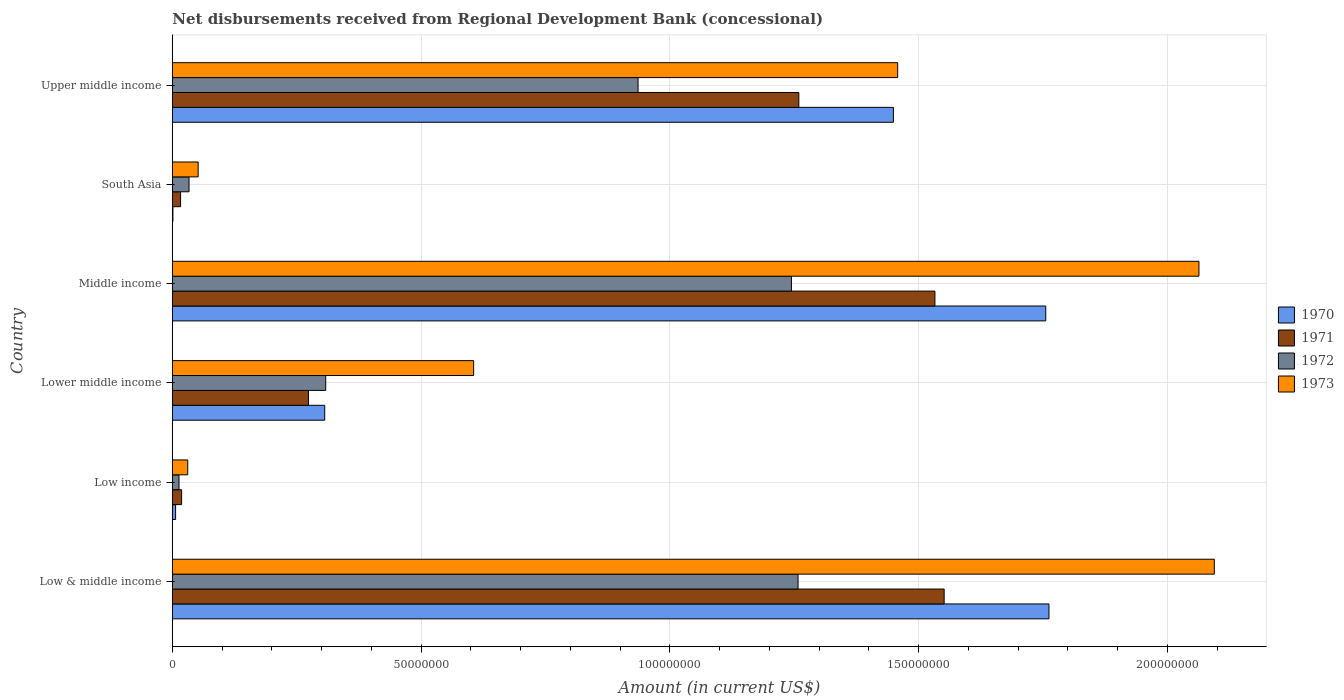How many different coloured bars are there?
Provide a succinct answer. 4. How many groups of bars are there?
Give a very brief answer. 6. Are the number of bars on each tick of the Y-axis equal?
Offer a terse response. Yes. What is the label of the 5th group of bars from the top?
Make the answer very short. Low income. In how many cases, is the number of bars for a given country not equal to the number of legend labels?
Make the answer very short. 0. What is the amount of disbursements received from Regional Development Bank in 1973 in South Asia?
Your response must be concise. 5.18e+06. Across all countries, what is the maximum amount of disbursements received from Regional Development Bank in 1971?
Provide a short and direct response. 1.55e+08. Across all countries, what is the minimum amount of disbursements received from Regional Development Bank in 1973?
Provide a short and direct response. 3.09e+06. In which country was the amount of disbursements received from Regional Development Bank in 1971 maximum?
Offer a very short reply. Low & middle income. In which country was the amount of disbursements received from Regional Development Bank in 1970 minimum?
Offer a terse response. South Asia. What is the total amount of disbursements received from Regional Development Bank in 1973 in the graph?
Your response must be concise. 6.30e+08. What is the difference between the amount of disbursements received from Regional Development Bank in 1971 in Middle income and that in Upper middle income?
Ensure brevity in your answer.  2.74e+07. What is the difference between the amount of disbursements received from Regional Development Bank in 1972 in Low income and the amount of disbursements received from Regional Development Bank in 1970 in Upper middle income?
Your answer should be very brief. -1.44e+08. What is the average amount of disbursements received from Regional Development Bank in 1971 per country?
Provide a succinct answer. 7.75e+07. What is the difference between the amount of disbursements received from Regional Development Bank in 1973 and amount of disbursements received from Regional Development Bank in 1970 in Low & middle income?
Your response must be concise. 3.32e+07. What is the ratio of the amount of disbursements received from Regional Development Bank in 1971 in Low income to that in South Asia?
Ensure brevity in your answer.  1.13. Is the amount of disbursements received from Regional Development Bank in 1972 in Low income less than that in South Asia?
Your response must be concise. Yes. What is the difference between the highest and the second highest amount of disbursements received from Regional Development Bank in 1971?
Your answer should be very brief. 1.86e+06. What is the difference between the highest and the lowest amount of disbursements received from Regional Development Bank in 1970?
Provide a succinct answer. 1.76e+08. In how many countries, is the amount of disbursements received from Regional Development Bank in 1971 greater than the average amount of disbursements received from Regional Development Bank in 1971 taken over all countries?
Your answer should be very brief. 3. Is it the case that in every country, the sum of the amount of disbursements received from Regional Development Bank in 1971 and amount of disbursements received from Regional Development Bank in 1972 is greater than the sum of amount of disbursements received from Regional Development Bank in 1973 and amount of disbursements received from Regional Development Bank in 1970?
Ensure brevity in your answer.  No. What does the 3rd bar from the top in South Asia represents?
Your answer should be very brief. 1971. What does the 2nd bar from the bottom in Lower middle income represents?
Provide a short and direct response. 1971. Are all the bars in the graph horizontal?
Give a very brief answer. Yes. How many countries are there in the graph?
Ensure brevity in your answer.  6. What is the difference between two consecutive major ticks on the X-axis?
Your response must be concise. 5.00e+07. Are the values on the major ticks of X-axis written in scientific E-notation?
Ensure brevity in your answer.  No. Does the graph contain any zero values?
Offer a terse response. No. How many legend labels are there?
Give a very brief answer. 4. How are the legend labels stacked?
Your response must be concise. Vertical. What is the title of the graph?
Give a very brief answer. Net disbursements received from Regional Development Bank (concessional). Does "1987" appear as one of the legend labels in the graph?
Make the answer very short. No. What is the Amount (in current US$) in 1970 in Low & middle income?
Make the answer very short. 1.76e+08. What is the Amount (in current US$) in 1971 in Low & middle income?
Provide a short and direct response. 1.55e+08. What is the Amount (in current US$) of 1972 in Low & middle income?
Offer a terse response. 1.26e+08. What is the Amount (in current US$) of 1973 in Low & middle income?
Your answer should be compact. 2.09e+08. What is the Amount (in current US$) in 1970 in Low income?
Keep it short and to the point. 6.47e+05. What is the Amount (in current US$) in 1971 in Low income?
Your answer should be very brief. 1.86e+06. What is the Amount (in current US$) of 1972 in Low income?
Give a very brief answer. 1.33e+06. What is the Amount (in current US$) of 1973 in Low income?
Ensure brevity in your answer.  3.09e+06. What is the Amount (in current US$) of 1970 in Lower middle income?
Offer a terse response. 3.06e+07. What is the Amount (in current US$) of 1971 in Lower middle income?
Offer a terse response. 2.74e+07. What is the Amount (in current US$) of 1972 in Lower middle income?
Make the answer very short. 3.08e+07. What is the Amount (in current US$) in 1973 in Lower middle income?
Your response must be concise. 6.06e+07. What is the Amount (in current US$) in 1970 in Middle income?
Offer a terse response. 1.76e+08. What is the Amount (in current US$) in 1971 in Middle income?
Your answer should be very brief. 1.53e+08. What is the Amount (in current US$) of 1972 in Middle income?
Your answer should be very brief. 1.24e+08. What is the Amount (in current US$) of 1973 in Middle income?
Your response must be concise. 2.06e+08. What is the Amount (in current US$) in 1970 in South Asia?
Provide a succinct answer. 1.09e+05. What is the Amount (in current US$) in 1971 in South Asia?
Offer a terse response. 1.65e+06. What is the Amount (in current US$) of 1972 in South Asia?
Offer a terse response. 3.35e+06. What is the Amount (in current US$) in 1973 in South Asia?
Offer a very short reply. 5.18e+06. What is the Amount (in current US$) in 1970 in Upper middle income?
Offer a very short reply. 1.45e+08. What is the Amount (in current US$) of 1971 in Upper middle income?
Your answer should be compact. 1.26e+08. What is the Amount (in current US$) of 1972 in Upper middle income?
Make the answer very short. 9.36e+07. What is the Amount (in current US$) in 1973 in Upper middle income?
Provide a short and direct response. 1.46e+08. Across all countries, what is the maximum Amount (in current US$) of 1970?
Offer a terse response. 1.76e+08. Across all countries, what is the maximum Amount (in current US$) of 1971?
Your response must be concise. 1.55e+08. Across all countries, what is the maximum Amount (in current US$) in 1972?
Make the answer very short. 1.26e+08. Across all countries, what is the maximum Amount (in current US$) of 1973?
Offer a very short reply. 2.09e+08. Across all countries, what is the minimum Amount (in current US$) in 1970?
Provide a succinct answer. 1.09e+05. Across all countries, what is the minimum Amount (in current US$) in 1971?
Offer a very short reply. 1.65e+06. Across all countries, what is the minimum Amount (in current US$) in 1972?
Provide a succinct answer. 1.33e+06. Across all countries, what is the minimum Amount (in current US$) in 1973?
Provide a short and direct response. 3.09e+06. What is the total Amount (in current US$) of 1970 in the graph?
Keep it short and to the point. 5.28e+08. What is the total Amount (in current US$) in 1971 in the graph?
Offer a very short reply. 4.65e+08. What is the total Amount (in current US$) in 1972 in the graph?
Offer a terse response. 3.79e+08. What is the total Amount (in current US$) in 1973 in the graph?
Provide a succinct answer. 6.30e+08. What is the difference between the Amount (in current US$) of 1970 in Low & middle income and that in Low income?
Offer a very short reply. 1.76e+08. What is the difference between the Amount (in current US$) of 1971 in Low & middle income and that in Low income?
Offer a terse response. 1.53e+08. What is the difference between the Amount (in current US$) of 1972 in Low & middle income and that in Low income?
Your answer should be very brief. 1.24e+08. What is the difference between the Amount (in current US$) of 1973 in Low & middle income and that in Low income?
Your answer should be very brief. 2.06e+08. What is the difference between the Amount (in current US$) in 1970 in Low & middle income and that in Lower middle income?
Keep it short and to the point. 1.46e+08. What is the difference between the Amount (in current US$) in 1971 in Low & middle income and that in Lower middle income?
Offer a very short reply. 1.28e+08. What is the difference between the Amount (in current US$) of 1972 in Low & middle income and that in Lower middle income?
Make the answer very short. 9.49e+07. What is the difference between the Amount (in current US$) of 1973 in Low & middle income and that in Lower middle income?
Ensure brevity in your answer.  1.49e+08. What is the difference between the Amount (in current US$) of 1970 in Low & middle income and that in Middle income?
Offer a very short reply. 6.47e+05. What is the difference between the Amount (in current US$) in 1971 in Low & middle income and that in Middle income?
Your answer should be very brief. 1.86e+06. What is the difference between the Amount (in current US$) of 1972 in Low & middle income and that in Middle income?
Your answer should be compact. 1.33e+06. What is the difference between the Amount (in current US$) of 1973 in Low & middle income and that in Middle income?
Make the answer very short. 3.09e+06. What is the difference between the Amount (in current US$) in 1970 in Low & middle income and that in South Asia?
Keep it short and to the point. 1.76e+08. What is the difference between the Amount (in current US$) of 1971 in Low & middle income and that in South Asia?
Provide a short and direct response. 1.53e+08. What is the difference between the Amount (in current US$) in 1972 in Low & middle income and that in South Asia?
Give a very brief answer. 1.22e+08. What is the difference between the Amount (in current US$) of 1973 in Low & middle income and that in South Asia?
Offer a very short reply. 2.04e+08. What is the difference between the Amount (in current US$) of 1970 in Low & middle income and that in Upper middle income?
Make the answer very short. 3.13e+07. What is the difference between the Amount (in current US$) of 1971 in Low & middle income and that in Upper middle income?
Give a very brief answer. 2.92e+07. What is the difference between the Amount (in current US$) of 1972 in Low & middle income and that in Upper middle income?
Offer a very short reply. 3.22e+07. What is the difference between the Amount (in current US$) in 1973 in Low & middle income and that in Upper middle income?
Provide a short and direct response. 6.36e+07. What is the difference between the Amount (in current US$) of 1970 in Low income and that in Lower middle income?
Provide a succinct answer. -3.00e+07. What is the difference between the Amount (in current US$) in 1971 in Low income and that in Lower middle income?
Provide a short and direct response. -2.55e+07. What is the difference between the Amount (in current US$) in 1972 in Low income and that in Lower middle income?
Keep it short and to the point. -2.95e+07. What is the difference between the Amount (in current US$) of 1973 in Low income and that in Lower middle income?
Your answer should be very brief. -5.75e+07. What is the difference between the Amount (in current US$) in 1970 in Low income and that in Middle income?
Keep it short and to the point. -1.75e+08. What is the difference between the Amount (in current US$) of 1971 in Low income and that in Middle income?
Give a very brief answer. -1.51e+08. What is the difference between the Amount (in current US$) in 1972 in Low income and that in Middle income?
Your answer should be compact. -1.23e+08. What is the difference between the Amount (in current US$) of 1973 in Low income and that in Middle income?
Your answer should be compact. -2.03e+08. What is the difference between the Amount (in current US$) of 1970 in Low income and that in South Asia?
Provide a succinct answer. 5.38e+05. What is the difference between the Amount (in current US$) in 1971 in Low income and that in South Asia?
Offer a terse response. 2.09e+05. What is the difference between the Amount (in current US$) in 1972 in Low income and that in South Asia?
Your answer should be very brief. -2.02e+06. What is the difference between the Amount (in current US$) in 1973 in Low income and that in South Asia?
Your answer should be compact. -2.09e+06. What is the difference between the Amount (in current US$) of 1970 in Low income and that in Upper middle income?
Keep it short and to the point. -1.44e+08. What is the difference between the Amount (in current US$) in 1971 in Low income and that in Upper middle income?
Keep it short and to the point. -1.24e+08. What is the difference between the Amount (in current US$) of 1972 in Low income and that in Upper middle income?
Ensure brevity in your answer.  -9.23e+07. What is the difference between the Amount (in current US$) of 1973 in Low income and that in Upper middle income?
Offer a very short reply. -1.43e+08. What is the difference between the Amount (in current US$) of 1970 in Lower middle income and that in Middle income?
Keep it short and to the point. -1.45e+08. What is the difference between the Amount (in current US$) in 1971 in Lower middle income and that in Middle income?
Your response must be concise. -1.26e+08. What is the difference between the Amount (in current US$) of 1972 in Lower middle income and that in Middle income?
Give a very brief answer. -9.36e+07. What is the difference between the Amount (in current US$) of 1973 in Lower middle income and that in Middle income?
Offer a terse response. -1.46e+08. What is the difference between the Amount (in current US$) of 1970 in Lower middle income and that in South Asia?
Provide a short and direct response. 3.05e+07. What is the difference between the Amount (in current US$) of 1971 in Lower middle income and that in South Asia?
Your answer should be very brief. 2.57e+07. What is the difference between the Amount (in current US$) of 1972 in Lower middle income and that in South Asia?
Provide a short and direct response. 2.75e+07. What is the difference between the Amount (in current US$) in 1973 in Lower middle income and that in South Asia?
Make the answer very short. 5.54e+07. What is the difference between the Amount (in current US$) in 1970 in Lower middle income and that in Upper middle income?
Offer a terse response. -1.14e+08. What is the difference between the Amount (in current US$) of 1971 in Lower middle income and that in Upper middle income?
Your answer should be compact. -9.86e+07. What is the difference between the Amount (in current US$) of 1972 in Lower middle income and that in Upper middle income?
Your answer should be very brief. -6.28e+07. What is the difference between the Amount (in current US$) in 1973 in Lower middle income and that in Upper middle income?
Make the answer very short. -8.52e+07. What is the difference between the Amount (in current US$) in 1970 in Middle income and that in South Asia?
Offer a terse response. 1.75e+08. What is the difference between the Amount (in current US$) in 1971 in Middle income and that in South Asia?
Give a very brief answer. 1.52e+08. What is the difference between the Amount (in current US$) of 1972 in Middle income and that in South Asia?
Ensure brevity in your answer.  1.21e+08. What is the difference between the Amount (in current US$) in 1973 in Middle income and that in South Asia?
Your response must be concise. 2.01e+08. What is the difference between the Amount (in current US$) in 1970 in Middle income and that in Upper middle income?
Your answer should be very brief. 3.06e+07. What is the difference between the Amount (in current US$) in 1971 in Middle income and that in Upper middle income?
Ensure brevity in your answer.  2.74e+07. What is the difference between the Amount (in current US$) of 1972 in Middle income and that in Upper middle income?
Your answer should be compact. 3.08e+07. What is the difference between the Amount (in current US$) of 1973 in Middle income and that in Upper middle income?
Offer a very short reply. 6.06e+07. What is the difference between the Amount (in current US$) of 1970 in South Asia and that in Upper middle income?
Keep it short and to the point. -1.45e+08. What is the difference between the Amount (in current US$) in 1971 in South Asia and that in Upper middle income?
Offer a terse response. -1.24e+08. What is the difference between the Amount (in current US$) of 1972 in South Asia and that in Upper middle income?
Offer a terse response. -9.03e+07. What is the difference between the Amount (in current US$) in 1973 in South Asia and that in Upper middle income?
Make the answer very short. -1.41e+08. What is the difference between the Amount (in current US$) of 1970 in Low & middle income and the Amount (in current US$) of 1971 in Low income?
Your response must be concise. 1.74e+08. What is the difference between the Amount (in current US$) in 1970 in Low & middle income and the Amount (in current US$) in 1972 in Low income?
Provide a succinct answer. 1.75e+08. What is the difference between the Amount (in current US$) of 1970 in Low & middle income and the Amount (in current US$) of 1973 in Low income?
Offer a terse response. 1.73e+08. What is the difference between the Amount (in current US$) in 1971 in Low & middle income and the Amount (in current US$) in 1972 in Low income?
Your answer should be compact. 1.54e+08. What is the difference between the Amount (in current US$) of 1971 in Low & middle income and the Amount (in current US$) of 1973 in Low income?
Keep it short and to the point. 1.52e+08. What is the difference between the Amount (in current US$) in 1972 in Low & middle income and the Amount (in current US$) in 1973 in Low income?
Offer a terse response. 1.23e+08. What is the difference between the Amount (in current US$) of 1970 in Low & middle income and the Amount (in current US$) of 1971 in Lower middle income?
Offer a very short reply. 1.49e+08. What is the difference between the Amount (in current US$) in 1970 in Low & middle income and the Amount (in current US$) in 1972 in Lower middle income?
Provide a short and direct response. 1.45e+08. What is the difference between the Amount (in current US$) in 1970 in Low & middle income and the Amount (in current US$) in 1973 in Lower middle income?
Offer a terse response. 1.16e+08. What is the difference between the Amount (in current US$) in 1971 in Low & middle income and the Amount (in current US$) in 1972 in Lower middle income?
Ensure brevity in your answer.  1.24e+08. What is the difference between the Amount (in current US$) in 1971 in Low & middle income and the Amount (in current US$) in 1973 in Lower middle income?
Your answer should be compact. 9.46e+07. What is the difference between the Amount (in current US$) in 1972 in Low & middle income and the Amount (in current US$) in 1973 in Lower middle income?
Make the answer very short. 6.52e+07. What is the difference between the Amount (in current US$) in 1970 in Low & middle income and the Amount (in current US$) in 1971 in Middle income?
Your response must be concise. 2.29e+07. What is the difference between the Amount (in current US$) of 1970 in Low & middle income and the Amount (in current US$) of 1972 in Middle income?
Make the answer very short. 5.18e+07. What is the difference between the Amount (in current US$) in 1970 in Low & middle income and the Amount (in current US$) in 1973 in Middle income?
Ensure brevity in your answer.  -3.01e+07. What is the difference between the Amount (in current US$) of 1971 in Low & middle income and the Amount (in current US$) of 1972 in Middle income?
Give a very brief answer. 3.07e+07. What is the difference between the Amount (in current US$) in 1971 in Low & middle income and the Amount (in current US$) in 1973 in Middle income?
Your response must be concise. -5.12e+07. What is the difference between the Amount (in current US$) of 1972 in Low & middle income and the Amount (in current US$) of 1973 in Middle income?
Offer a very short reply. -8.06e+07. What is the difference between the Amount (in current US$) in 1970 in Low & middle income and the Amount (in current US$) in 1971 in South Asia?
Keep it short and to the point. 1.75e+08. What is the difference between the Amount (in current US$) in 1970 in Low & middle income and the Amount (in current US$) in 1972 in South Asia?
Give a very brief answer. 1.73e+08. What is the difference between the Amount (in current US$) of 1970 in Low & middle income and the Amount (in current US$) of 1973 in South Asia?
Offer a terse response. 1.71e+08. What is the difference between the Amount (in current US$) of 1971 in Low & middle income and the Amount (in current US$) of 1972 in South Asia?
Ensure brevity in your answer.  1.52e+08. What is the difference between the Amount (in current US$) in 1971 in Low & middle income and the Amount (in current US$) in 1973 in South Asia?
Provide a short and direct response. 1.50e+08. What is the difference between the Amount (in current US$) of 1972 in Low & middle income and the Amount (in current US$) of 1973 in South Asia?
Your answer should be compact. 1.21e+08. What is the difference between the Amount (in current US$) in 1970 in Low & middle income and the Amount (in current US$) in 1971 in Upper middle income?
Keep it short and to the point. 5.03e+07. What is the difference between the Amount (in current US$) in 1970 in Low & middle income and the Amount (in current US$) in 1972 in Upper middle income?
Provide a short and direct response. 8.26e+07. What is the difference between the Amount (in current US$) in 1970 in Low & middle income and the Amount (in current US$) in 1973 in Upper middle income?
Give a very brief answer. 3.04e+07. What is the difference between the Amount (in current US$) in 1971 in Low & middle income and the Amount (in current US$) in 1972 in Upper middle income?
Give a very brief answer. 6.15e+07. What is the difference between the Amount (in current US$) of 1971 in Low & middle income and the Amount (in current US$) of 1973 in Upper middle income?
Offer a very short reply. 9.34e+06. What is the difference between the Amount (in current US$) of 1972 in Low & middle income and the Amount (in current US$) of 1973 in Upper middle income?
Offer a very short reply. -2.00e+07. What is the difference between the Amount (in current US$) of 1970 in Low income and the Amount (in current US$) of 1971 in Lower middle income?
Your response must be concise. -2.67e+07. What is the difference between the Amount (in current US$) of 1970 in Low income and the Amount (in current US$) of 1972 in Lower middle income?
Your answer should be very brief. -3.02e+07. What is the difference between the Amount (in current US$) of 1970 in Low income and the Amount (in current US$) of 1973 in Lower middle income?
Offer a terse response. -5.99e+07. What is the difference between the Amount (in current US$) in 1971 in Low income and the Amount (in current US$) in 1972 in Lower middle income?
Offer a very short reply. -2.90e+07. What is the difference between the Amount (in current US$) of 1971 in Low income and the Amount (in current US$) of 1973 in Lower middle income?
Your answer should be very brief. -5.87e+07. What is the difference between the Amount (in current US$) of 1972 in Low income and the Amount (in current US$) of 1973 in Lower middle income?
Offer a terse response. -5.92e+07. What is the difference between the Amount (in current US$) of 1970 in Low income and the Amount (in current US$) of 1971 in Middle income?
Your answer should be compact. -1.53e+08. What is the difference between the Amount (in current US$) of 1970 in Low income and the Amount (in current US$) of 1972 in Middle income?
Your answer should be compact. -1.24e+08. What is the difference between the Amount (in current US$) in 1970 in Low income and the Amount (in current US$) in 1973 in Middle income?
Keep it short and to the point. -2.06e+08. What is the difference between the Amount (in current US$) in 1971 in Low income and the Amount (in current US$) in 1972 in Middle income?
Offer a very short reply. -1.23e+08. What is the difference between the Amount (in current US$) in 1971 in Low income and the Amount (in current US$) in 1973 in Middle income?
Your response must be concise. -2.04e+08. What is the difference between the Amount (in current US$) in 1972 in Low income and the Amount (in current US$) in 1973 in Middle income?
Make the answer very short. -2.05e+08. What is the difference between the Amount (in current US$) in 1970 in Low income and the Amount (in current US$) in 1971 in South Asia?
Your response must be concise. -1.00e+06. What is the difference between the Amount (in current US$) of 1970 in Low income and the Amount (in current US$) of 1972 in South Asia?
Offer a terse response. -2.70e+06. What is the difference between the Amount (in current US$) of 1970 in Low income and the Amount (in current US$) of 1973 in South Asia?
Your answer should be compact. -4.54e+06. What is the difference between the Amount (in current US$) of 1971 in Low income and the Amount (in current US$) of 1972 in South Asia?
Your answer should be compact. -1.49e+06. What is the difference between the Amount (in current US$) in 1971 in Low income and the Amount (in current US$) in 1973 in South Asia?
Your response must be concise. -3.32e+06. What is the difference between the Amount (in current US$) in 1972 in Low income and the Amount (in current US$) in 1973 in South Asia?
Provide a succinct answer. -3.85e+06. What is the difference between the Amount (in current US$) in 1970 in Low income and the Amount (in current US$) in 1971 in Upper middle income?
Your response must be concise. -1.25e+08. What is the difference between the Amount (in current US$) of 1970 in Low income and the Amount (in current US$) of 1972 in Upper middle income?
Your answer should be very brief. -9.30e+07. What is the difference between the Amount (in current US$) of 1970 in Low income and the Amount (in current US$) of 1973 in Upper middle income?
Ensure brevity in your answer.  -1.45e+08. What is the difference between the Amount (in current US$) in 1971 in Low income and the Amount (in current US$) in 1972 in Upper middle income?
Keep it short and to the point. -9.17e+07. What is the difference between the Amount (in current US$) in 1971 in Low income and the Amount (in current US$) in 1973 in Upper middle income?
Provide a short and direct response. -1.44e+08. What is the difference between the Amount (in current US$) in 1972 in Low income and the Amount (in current US$) in 1973 in Upper middle income?
Give a very brief answer. -1.44e+08. What is the difference between the Amount (in current US$) in 1970 in Lower middle income and the Amount (in current US$) in 1971 in Middle income?
Give a very brief answer. -1.23e+08. What is the difference between the Amount (in current US$) of 1970 in Lower middle income and the Amount (in current US$) of 1972 in Middle income?
Your response must be concise. -9.38e+07. What is the difference between the Amount (in current US$) of 1970 in Lower middle income and the Amount (in current US$) of 1973 in Middle income?
Your answer should be compact. -1.76e+08. What is the difference between the Amount (in current US$) in 1971 in Lower middle income and the Amount (in current US$) in 1972 in Middle income?
Provide a succinct answer. -9.71e+07. What is the difference between the Amount (in current US$) in 1971 in Lower middle income and the Amount (in current US$) in 1973 in Middle income?
Offer a very short reply. -1.79e+08. What is the difference between the Amount (in current US$) of 1972 in Lower middle income and the Amount (in current US$) of 1973 in Middle income?
Provide a short and direct response. -1.76e+08. What is the difference between the Amount (in current US$) of 1970 in Lower middle income and the Amount (in current US$) of 1971 in South Asia?
Offer a terse response. 2.90e+07. What is the difference between the Amount (in current US$) of 1970 in Lower middle income and the Amount (in current US$) of 1972 in South Asia?
Provide a short and direct response. 2.73e+07. What is the difference between the Amount (in current US$) in 1970 in Lower middle income and the Amount (in current US$) in 1973 in South Asia?
Provide a short and direct response. 2.54e+07. What is the difference between the Amount (in current US$) of 1971 in Lower middle income and the Amount (in current US$) of 1972 in South Asia?
Your answer should be very brief. 2.40e+07. What is the difference between the Amount (in current US$) of 1971 in Lower middle income and the Amount (in current US$) of 1973 in South Asia?
Your answer should be very brief. 2.22e+07. What is the difference between the Amount (in current US$) in 1972 in Lower middle income and the Amount (in current US$) in 1973 in South Asia?
Your answer should be compact. 2.56e+07. What is the difference between the Amount (in current US$) of 1970 in Lower middle income and the Amount (in current US$) of 1971 in Upper middle income?
Keep it short and to the point. -9.53e+07. What is the difference between the Amount (in current US$) in 1970 in Lower middle income and the Amount (in current US$) in 1972 in Upper middle income?
Offer a very short reply. -6.30e+07. What is the difference between the Amount (in current US$) of 1970 in Lower middle income and the Amount (in current US$) of 1973 in Upper middle income?
Ensure brevity in your answer.  -1.15e+08. What is the difference between the Amount (in current US$) in 1971 in Lower middle income and the Amount (in current US$) in 1972 in Upper middle income?
Keep it short and to the point. -6.63e+07. What is the difference between the Amount (in current US$) of 1971 in Lower middle income and the Amount (in current US$) of 1973 in Upper middle income?
Offer a very short reply. -1.18e+08. What is the difference between the Amount (in current US$) in 1972 in Lower middle income and the Amount (in current US$) in 1973 in Upper middle income?
Provide a short and direct response. -1.15e+08. What is the difference between the Amount (in current US$) in 1970 in Middle income and the Amount (in current US$) in 1971 in South Asia?
Ensure brevity in your answer.  1.74e+08. What is the difference between the Amount (in current US$) in 1970 in Middle income and the Amount (in current US$) in 1972 in South Asia?
Your response must be concise. 1.72e+08. What is the difference between the Amount (in current US$) in 1970 in Middle income and the Amount (in current US$) in 1973 in South Asia?
Keep it short and to the point. 1.70e+08. What is the difference between the Amount (in current US$) of 1971 in Middle income and the Amount (in current US$) of 1972 in South Asia?
Your response must be concise. 1.50e+08. What is the difference between the Amount (in current US$) of 1971 in Middle income and the Amount (in current US$) of 1973 in South Asia?
Offer a terse response. 1.48e+08. What is the difference between the Amount (in current US$) in 1972 in Middle income and the Amount (in current US$) in 1973 in South Asia?
Provide a succinct answer. 1.19e+08. What is the difference between the Amount (in current US$) in 1970 in Middle income and the Amount (in current US$) in 1971 in Upper middle income?
Your response must be concise. 4.96e+07. What is the difference between the Amount (in current US$) in 1970 in Middle income and the Amount (in current US$) in 1972 in Upper middle income?
Keep it short and to the point. 8.19e+07. What is the difference between the Amount (in current US$) in 1970 in Middle income and the Amount (in current US$) in 1973 in Upper middle income?
Offer a terse response. 2.98e+07. What is the difference between the Amount (in current US$) in 1971 in Middle income and the Amount (in current US$) in 1972 in Upper middle income?
Give a very brief answer. 5.97e+07. What is the difference between the Amount (in current US$) of 1971 in Middle income and the Amount (in current US$) of 1973 in Upper middle income?
Your response must be concise. 7.49e+06. What is the difference between the Amount (in current US$) of 1972 in Middle income and the Amount (in current US$) of 1973 in Upper middle income?
Your response must be concise. -2.14e+07. What is the difference between the Amount (in current US$) of 1970 in South Asia and the Amount (in current US$) of 1971 in Upper middle income?
Your answer should be very brief. -1.26e+08. What is the difference between the Amount (in current US$) of 1970 in South Asia and the Amount (in current US$) of 1972 in Upper middle income?
Provide a short and direct response. -9.35e+07. What is the difference between the Amount (in current US$) in 1970 in South Asia and the Amount (in current US$) in 1973 in Upper middle income?
Your response must be concise. -1.46e+08. What is the difference between the Amount (in current US$) in 1971 in South Asia and the Amount (in current US$) in 1972 in Upper middle income?
Provide a short and direct response. -9.20e+07. What is the difference between the Amount (in current US$) of 1971 in South Asia and the Amount (in current US$) of 1973 in Upper middle income?
Your response must be concise. -1.44e+08. What is the difference between the Amount (in current US$) in 1972 in South Asia and the Amount (in current US$) in 1973 in Upper middle income?
Make the answer very short. -1.42e+08. What is the average Amount (in current US$) of 1970 per country?
Keep it short and to the point. 8.80e+07. What is the average Amount (in current US$) in 1971 per country?
Keep it short and to the point. 7.75e+07. What is the average Amount (in current US$) in 1972 per country?
Keep it short and to the point. 6.32e+07. What is the average Amount (in current US$) in 1973 per country?
Keep it short and to the point. 1.05e+08. What is the difference between the Amount (in current US$) in 1970 and Amount (in current US$) in 1971 in Low & middle income?
Ensure brevity in your answer.  2.11e+07. What is the difference between the Amount (in current US$) of 1970 and Amount (in current US$) of 1972 in Low & middle income?
Offer a terse response. 5.04e+07. What is the difference between the Amount (in current US$) in 1970 and Amount (in current US$) in 1973 in Low & middle income?
Ensure brevity in your answer.  -3.32e+07. What is the difference between the Amount (in current US$) of 1971 and Amount (in current US$) of 1972 in Low & middle income?
Your answer should be very brief. 2.94e+07. What is the difference between the Amount (in current US$) of 1971 and Amount (in current US$) of 1973 in Low & middle income?
Provide a succinct answer. -5.43e+07. What is the difference between the Amount (in current US$) in 1972 and Amount (in current US$) in 1973 in Low & middle income?
Offer a terse response. -8.37e+07. What is the difference between the Amount (in current US$) in 1970 and Amount (in current US$) in 1971 in Low income?
Give a very brief answer. -1.21e+06. What is the difference between the Amount (in current US$) in 1970 and Amount (in current US$) in 1972 in Low income?
Your answer should be compact. -6.86e+05. What is the difference between the Amount (in current US$) in 1970 and Amount (in current US$) in 1973 in Low income?
Offer a very short reply. -2.44e+06. What is the difference between the Amount (in current US$) of 1971 and Amount (in current US$) of 1972 in Low income?
Provide a succinct answer. 5.26e+05. What is the difference between the Amount (in current US$) of 1971 and Amount (in current US$) of 1973 in Low income?
Ensure brevity in your answer.  -1.23e+06. What is the difference between the Amount (in current US$) in 1972 and Amount (in current US$) in 1973 in Low income?
Offer a very short reply. -1.76e+06. What is the difference between the Amount (in current US$) of 1970 and Amount (in current US$) of 1971 in Lower middle income?
Your answer should be very brief. 3.27e+06. What is the difference between the Amount (in current US$) of 1970 and Amount (in current US$) of 1972 in Lower middle income?
Ensure brevity in your answer.  -2.02e+05. What is the difference between the Amount (in current US$) in 1970 and Amount (in current US$) in 1973 in Lower middle income?
Offer a terse response. -2.99e+07. What is the difference between the Amount (in current US$) of 1971 and Amount (in current US$) of 1972 in Lower middle income?
Offer a terse response. -3.47e+06. What is the difference between the Amount (in current US$) in 1971 and Amount (in current US$) in 1973 in Lower middle income?
Give a very brief answer. -3.32e+07. What is the difference between the Amount (in current US$) in 1972 and Amount (in current US$) in 1973 in Lower middle income?
Your answer should be compact. -2.97e+07. What is the difference between the Amount (in current US$) of 1970 and Amount (in current US$) of 1971 in Middle income?
Provide a short and direct response. 2.23e+07. What is the difference between the Amount (in current US$) of 1970 and Amount (in current US$) of 1972 in Middle income?
Your answer should be compact. 5.11e+07. What is the difference between the Amount (in current US$) of 1970 and Amount (in current US$) of 1973 in Middle income?
Make the answer very short. -3.08e+07. What is the difference between the Amount (in current US$) in 1971 and Amount (in current US$) in 1972 in Middle income?
Keep it short and to the point. 2.88e+07. What is the difference between the Amount (in current US$) in 1971 and Amount (in current US$) in 1973 in Middle income?
Make the answer very short. -5.31e+07. What is the difference between the Amount (in current US$) in 1972 and Amount (in current US$) in 1973 in Middle income?
Provide a succinct answer. -8.19e+07. What is the difference between the Amount (in current US$) in 1970 and Amount (in current US$) in 1971 in South Asia?
Ensure brevity in your answer.  -1.54e+06. What is the difference between the Amount (in current US$) in 1970 and Amount (in current US$) in 1972 in South Asia?
Your answer should be very brief. -3.24e+06. What is the difference between the Amount (in current US$) in 1970 and Amount (in current US$) in 1973 in South Asia?
Your answer should be compact. -5.08e+06. What is the difference between the Amount (in current US$) in 1971 and Amount (in current US$) in 1972 in South Asia?
Provide a succinct answer. -1.70e+06. What is the difference between the Amount (in current US$) of 1971 and Amount (in current US$) of 1973 in South Asia?
Offer a terse response. -3.53e+06. What is the difference between the Amount (in current US$) of 1972 and Amount (in current US$) of 1973 in South Asia?
Give a very brief answer. -1.83e+06. What is the difference between the Amount (in current US$) in 1970 and Amount (in current US$) in 1971 in Upper middle income?
Keep it short and to the point. 1.90e+07. What is the difference between the Amount (in current US$) of 1970 and Amount (in current US$) of 1972 in Upper middle income?
Keep it short and to the point. 5.13e+07. What is the difference between the Amount (in current US$) in 1970 and Amount (in current US$) in 1973 in Upper middle income?
Ensure brevity in your answer.  -8.58e+05. What is the difference between the Amount (in current US$) of 1971 and Amount (in current US$) of 1972 in Upper middle income?
Your response must be concise. 3.23e+07. What is the difference between the Amount (in current US$) in 1971 and Amount (in current US$) in 1973 in Upper middle income?
Provide a succinct answer. -1.99e+07. What is the difference between the Amount (in current US$) in 1972 and Amount (in current US$) in 1973 in Upper middle income?
Your response must be concise. -5.22e+07. What is the ratio of the Amount (in current US$) of 1970 in Low & middle income to that in Low income?
Offer a very short reply. 272.33. What is the ratio of the Amount (in current US$) of 1971 in Low & middle income to that in Low income?
Ensure brevity in your answer.  83.45. What is the ratio of the Amount (in current US$) of 1972 in Low & middle income to that in Low income?
Ensure brevity in your answer.  94.35. What is the ratio of the Amount (in current US$) in 1973 in Low & middle income to that in Low income?
Your answer should be compact. 67.76. What is the ratio of the Amount (in current US$) of 1970 in Low & middle income to that in Lower middle income?
Your response must be concise. 5.75. What is the ratio of the Amount (in current US$) of 1971 in Low & middle income to that in Lower middle income?
Your answer should be very brief. 5.67. What is the ratio of the Amount (in current US$) of 1972 in Low & middle income to that in Lower middle income?
Offer a terse response. 4.08. What is the ratio of the Amount (in current US$) of 1973 in Low & middle income to that in Lower middle income?
Make the answer very short. 3.46. What is the ratio of the Amount (in current US$) in 1971 in Low & middle income to that in Middle income?
Offer a very short reply. 1.01. What is the ratio of the Amount (in current US$) in 1972 in Low & middle income to that in Middle income?
Make the answer very short. 1.01. What is the ratio of the Amount (in current US$) of 1970 in Low & middle income to that in South Asia?
Provide a succinct answer. 1616.51. What is the ratio of the Amount (in current US$) in 1971 in Low & middle income to that in South Asia?
Provide a short and direct response. 94.02. What is the ratio of the Amount (in current US$) in 1972 in Low & middle income to that in South Asia?
Your response must be concise. 37.54. What is the ratio of the Amount (in current US$) in 1973 in Low & middle income to that in South Asia?
Keep it short and to the point. 40.4. What is the ratio of the Amount (in current US$) of 1970 in Low & middle income to that in Upper middle income?
Offer a very short reply. 1.22. What is the ratio of the Amount (in current US$) of 1971 in Low & middle income to that in Upper middle income?
Ensure brevity in your answer.  1.23. What is the ratio of the Amount (in current US$) in 1972 in Low & middle income to that in Upper middle income?
Offer a very short reply. 1.34. What is the ratio of the Amount (in current US$) in 1973 in Low & middle income to that in Upper middle income?
Make the answer very short. 1.44. What is the ratio of the Amount (in current US$) of 1970 in Low income to that in Lower middle income?
Provide a succinct answer. 0.02. What is the ratio of the Amount (in current US$) of 1971 in Low income to that in Lower middle income?
Keep it short and to the point. 0.07. What is the ratio of the Amount (in current US$) of 1972 in Low income to that in Lower middle income?
Your response must be concise. 0.04. What is the ratio of the Amount (in current US$) of 1973 in Low income to that in Lower middle income?
Your response must be concise. 0.05. What is the ratio of the Amount (in current US$) of 1970 in Low income to that in Middle income?
Provide a short and direct response. 0. What is the ratio of the Amount (in current US$) of 1971 in Low income to that in Middle income?
Ensure brevity in your answer.  0.01. What is the ratio of the Amount (in current US$) in 1972 in Low income to that in Middle income?
Provide a succinct answer. 0.01. What is the ratio of the Amount (in current US$) in 1973 in Low income to that in Middle income?
Keep it short and to the point. 0.01. What is the ratio of the Amount (in current US$) in 1970 in Low income to that in South Asia?
Provide a succinct answer. 5.94. What is the ratio of the Amount (in current US$) in 1971 in Low income to that in South Asia?
Your answer should be compact. 1.13. What is the ratio of the Amount (in current US$) of 1972 in Low income to that in South Asia?
Your answer should be very brief. 0.4. What is the ratio of the Amount (in current US$) in 1973 in Low income to that in South Asia?
Offer a very short reply. 0.6. What is the ratio of the Amount (in current US$) in 1970 in Low income to that in Upper middle income?
Your answer should be very brief. 0. What is the ratio of the Amount (in current US$) in 1971 in Low income to that in Upper middle income?
Your response must be concise. 0.01. What is the ratio of the Amount (in current US$) of 1972 in Low income to that in Upper middle income?
Your answer should be compact. 0.01. What is the ratio of the Amount (in current US$) in 1973 in Low income to that in Upper middle income?
Your answer should be very brief. 0.02. What is the ratio of the Amount (in current US$) in 1970 in Lower middle income to that in Middle income?
Give a very brief answer. 0.17. What is the ratio of the Amount (in current US$) in 1971 in Lower middle income to that in Middle income?
Give a very brief answer. 0.18. What is the ratio of the Amount (in current US$) in 1972 in Lower middle income to that in Middle income?
Offer a terse response. 0.25. What is the ratio of the Amount (in current US$) of 1973 in Lower middle income to that in Middle income?
Provide a short and direct response. 0.29. What is the ratio of the Amount (in current US$) in 1970 in Lower middle income to that in South Asia?
Your response must be concise. 280.94. What is the ratio of the Amount (in current US$) in 1971 in Lower middle income to that in South Asia?
Provide a short and direct response. 16.58. What is the ratio of the Amount (in current US$) of 1972 in Lower middle income to that in South Asia?
Keep it short and to the point. 9.2. What is the ratio of the Amount (in current US$) of 1973 in Lower middle income to that in South Asia?
Your answer should be compact. 11.68. What is the ratio of the Amount (in current US$) of 1970 in Lower middle income to that in Upper middle income?
Your response must be concise. 0.21. What is the ratio of the Amount (in current US$) in 1971 in Lower middle income to that in Upper middle income?
Provide a succinct answer. 0.22. What is the ratio of the Amount (in current US$) in 1972 in Lower middle income to that in Upper middle income?
Give a very brief answer. 0.33. What is the ratio of the Amount (in current US$) of 1973 in Lower middle income to that in Upper middle income?
Provide a short and direct response. 0.42. What is the ratio of the Amount (in current US$) in 1970 in Middle income to that in South Asia?
Make the answer very short. 1610.58. What is the ratio of the Amount (in current US$) of 1971 in Middle income to that in South Asia?
Keep it short and to the point. 92.89. What is the ratio of the Amount (in current US$) in 1972 in Middle income to that in South Asia?
Your answer should be very brief. 37.14. What is the ratio of the Amount (in current US$) in 1973 in Middle income to that in South Asia?
Your response must be concise. 39.8. What is the ratio of the Amount (in current US$) of 1970 in Middle income to that in Upper middle income?
Give a very brief answer. 1.21. What is the ratio of the Amount (in current US$) of 1971 in Middle income to that in Upper middle income?
Provide a succinct answer. 1.22. What is the ratio of the Amount (in current US$) in 1972 in Middle income to that in Upper middle income?
Keep it short and to the point. 1.33. What is the ratio of the Amount (in current US$) of 1973 in Middle income to that in Upper middle income?
Ensure brevity in your answer.  1.42. What is the ratio of the Amount (in current US$) of 1970 in South Asia to that in Upper middle income?
Make the answer very short. 0. What is the ratio of the Amount (in current US$) in 1971 in South Asia to that in Upper middle income?
Make the answer very short. 0.01. What is the ratio of the Amount (in current US$) of 1972 in South Asia to that in Upper middle income?
Provide a succinct answer. 0.04. What is the ratio of the Amount (in current US$) of 1973 in South Asia to that in Upper middle income?
Offer a terse response. 0.04. What is the difference between the highest and the second highest Amount (in current US$) of 1970?
Ensure brevity in your answer.  6.47e+05. What is the difference between the highest and the second highest Amount (in current US$) of 1971?
Offer a very short reply. 1.86e+06. What is the difference between the highest and the second highest Amount (in current US$) of 1972?
Provide a short and direct response. 1.33e+06. What is the difference between the highest and the second highest Amount (in current US$) of 1973?
Offer a very short reply. 3.09e+06. What is the difference between the highest and the lowest Amount (in current US$) of 1970?
Ensure brevity in your answer.  1.76e+08. What is the difference between the highest and the lowest Amount (in current US$) in 1971?
Offer a very short reply. 1.53e+08. What is the difference between the highest and the lowest Amount (in current US$) of 1972?
Give a very brief answer. 1.24e+08. What is the difference between the highest and the lowest Amount (in current US$) of 1973?
Keep it short and to the point. 2.06e+08. 